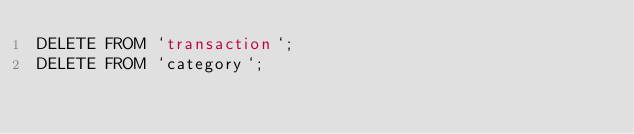<code> <loc_0><loc_0><loc_500><loc_500><_SQL_>DELETE FROM `transaction`;
DELETE FROM `category`;
</code> 